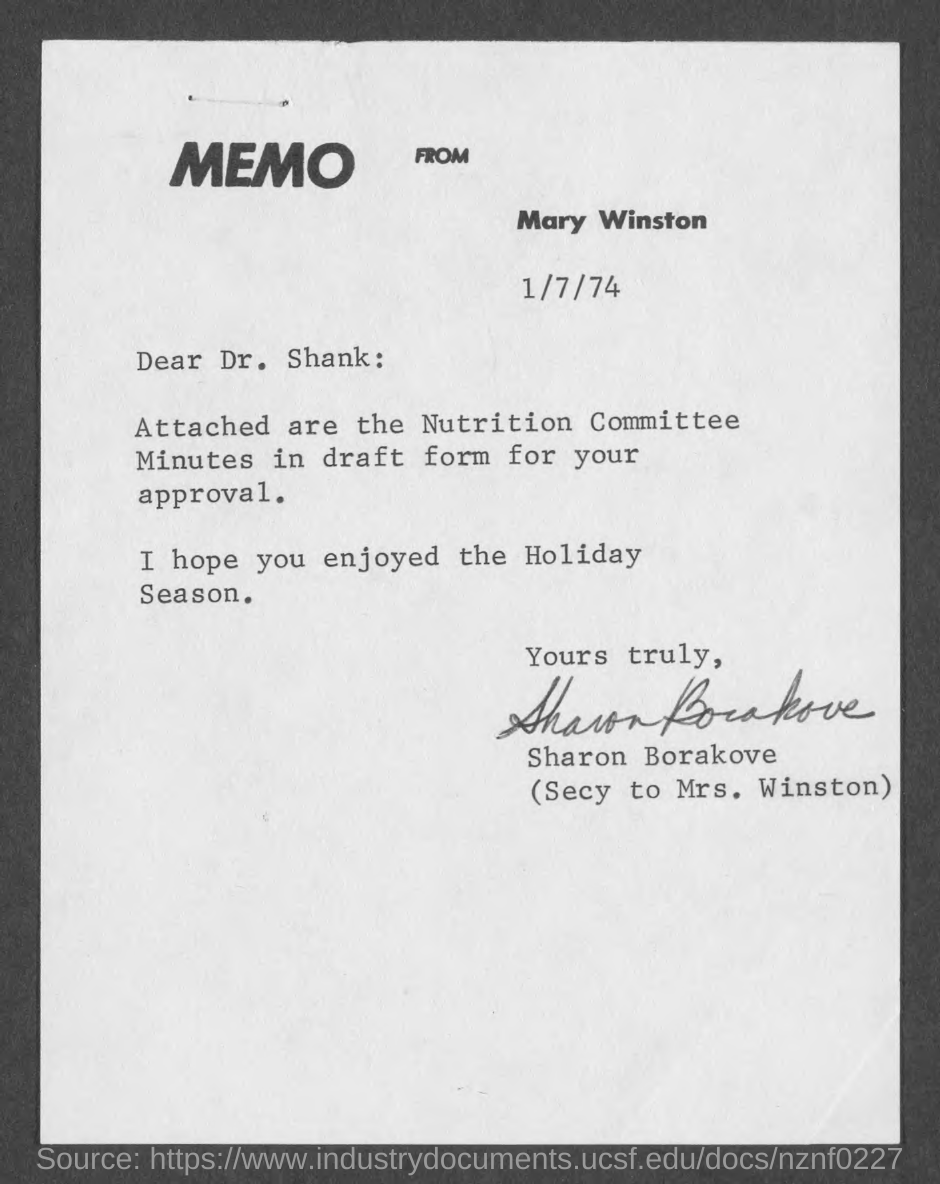List a handful of essential elements in this visual. This is a type of communication known as a memo. The sender of this memo is Mary Winston. The date mentioned in the memo is 1/7/74. The memo has been signed by Sharon Borakove. The addressee of this memo is Dr. Shank. 